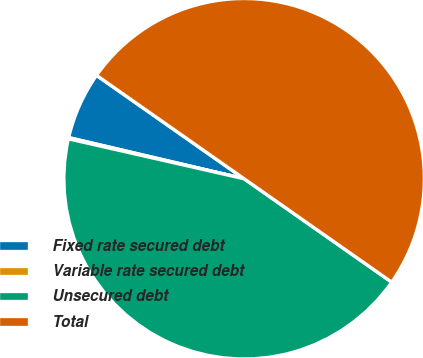<chart> <loc_0><loc_0><loc_500><loc_500><pie_chart><fcel>Fixed rate secured debt<fcel>Variable rate secured debt<fcel>Unsecured debt<fcel>Total<nl><fcel>6.06%<fcel>0.11%<fcel>43.83%<fcel>50.0%<nl></chart> 